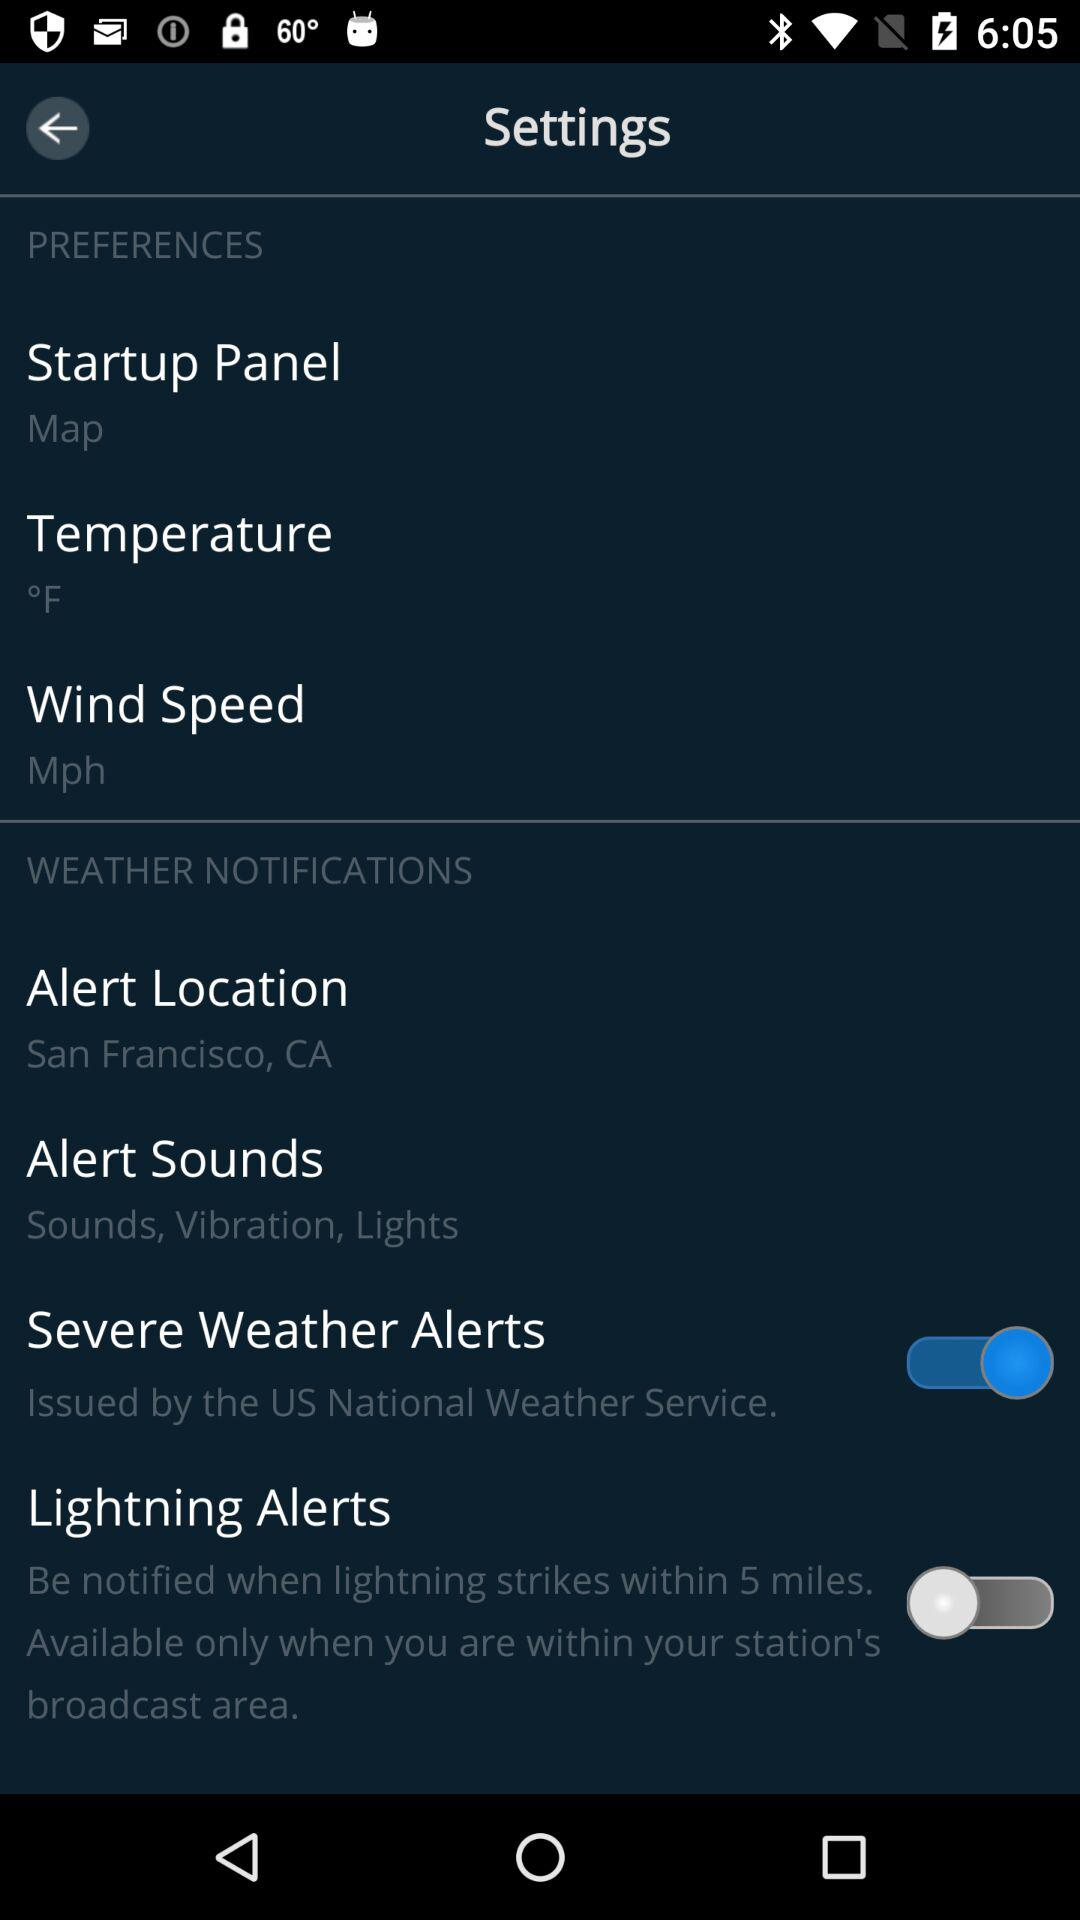What is the alert location? The alert location is San Francisco, CA. 